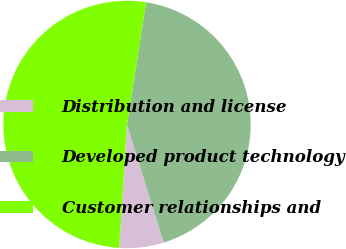Convert chart. <chart><loc_0><loc_0><loc_500><loc_500><pie_chart><fcel>Distribution and license<fcel>Developed product technology<fcel>Customer relationships and<nl><fcel>5.79%<fcel>42.76%<fcel>51.45%<nl></chart> 